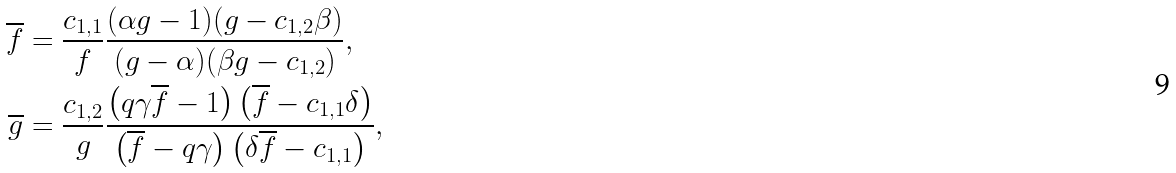Convert formula to latex. <formula><loc_0><loc_0><loc_500><loc_500>\overline { f } & = \frac { c _ { 1 , 1 } } { f } \frac { ( \alpha g - 1 ) ( g - c _ { 1 , 2 } \beta ) } { ( g - \alpha ) ( \beta g - c _ { 1 , 2 } ) } , \\ \overline { g } & = \frac { c _ { 1 , 2 } } { g } \frac { \left ( q \gamma \overline { f } - 1 \right ) \left ( \overline { f } - c _ { 1 , 1 } \delta \right ) } { \left ( \overline { f } - q \gamma \right ) \left ( \delta \overline { f } - c _ { 1 , 1 } \right ) } ,</formula> 